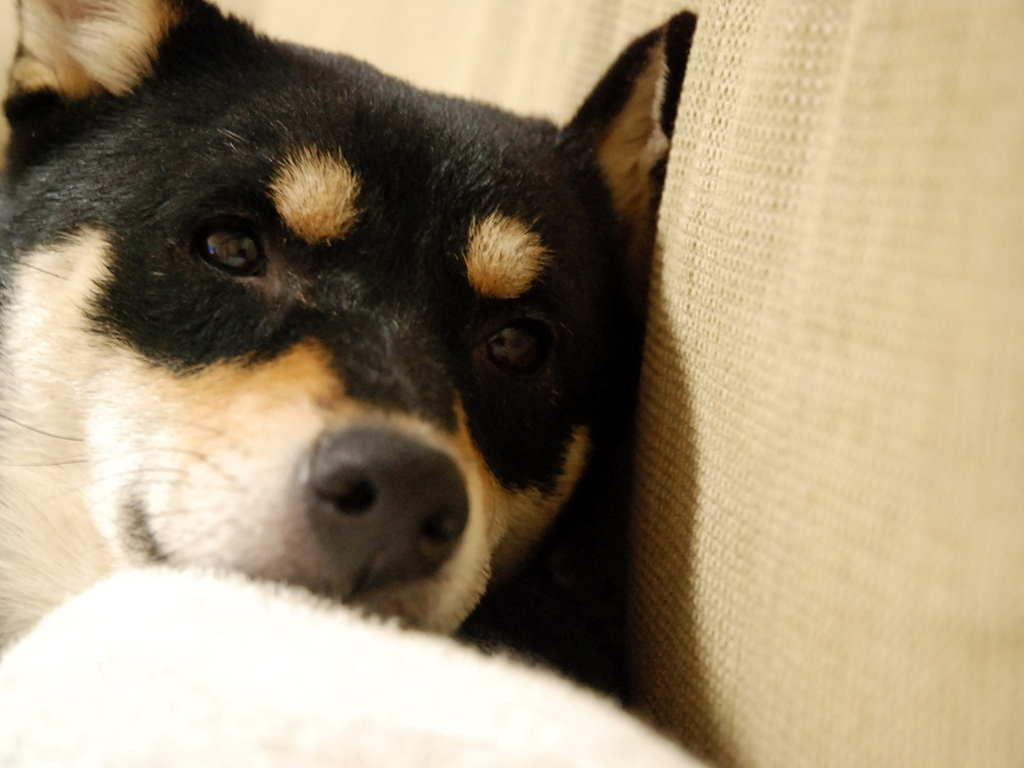What does the blurred background indicate?
A. Poor image quality.
B. Excellent image quality.
C. Average image quality.
D. Good image quality.
Answer with the option's letter from the given choices directly. The blurred background is a result of a shallow depth of field, commonly used to draw attention to the subject in the foreground, which in this case, is the dog. It is a technique used in photography to create separation between the subject and the background, contributing to what is typically considered to be excellent image quality for portraits or focused subjects. Therefore, the correct answer would be B. Excellent image quality, as it demonstrates intentionality and skill in the composition of the shot. 